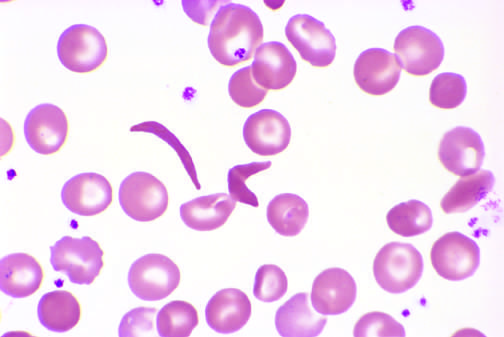does higher magnification show an irreversibly sickled cell in the center?
Answer the question using a single word or phrase. Yes 